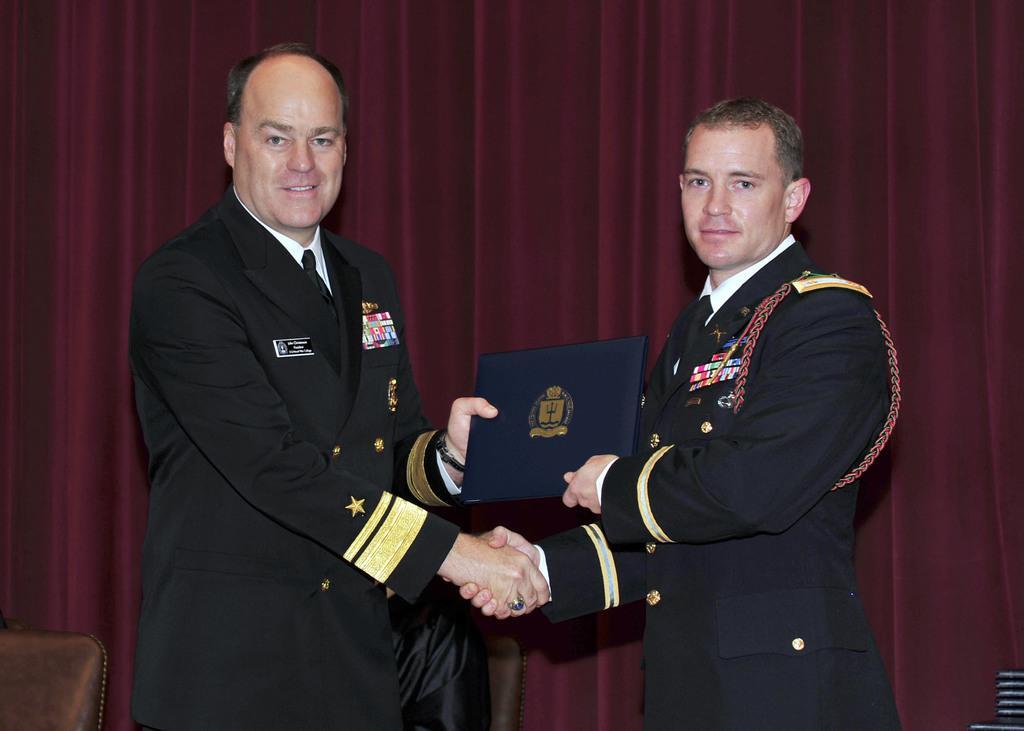Describe this image in one or two sentences. In this picture, we see two men who are in the uniform are standing. Both of them are shaking their hands and they are smiling. They are holding a certificate in their hands. They are posing for the photo. In the left bottom, we see a chair. In the background, we see a curtain or a sheet in maroon color. 